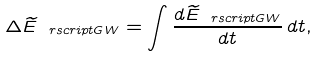<formula> <loc_0><loc_0><loc_500><loc_500>\Delta \widetilde { E } _ { \ r s c r i p t { G W } } = \int \frac { d \widetilde { E } _ { \ r s c r i p t { G W } } } { d t } \, d t ,</formula> 